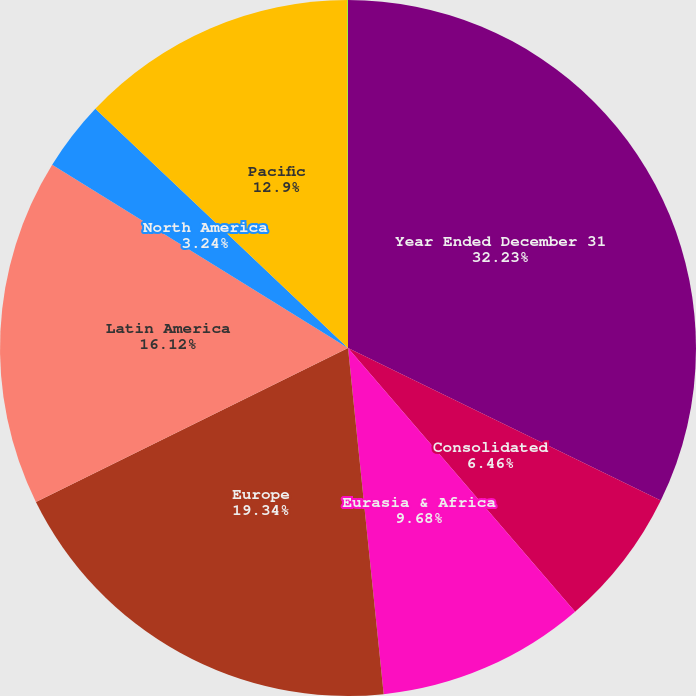Convert chart. <chart><loc_0><loc_0><loc_500><loc_500><pie_chart><fcel>Year Ended December 31<fcel>Consolidated<fcel>Eurasia & Africa<fcel>Europe<fcel>Latin America<fcel>North America<fcel>Pacific<fcel>Bottling Investments<nl><fcel>32.22%<fcel>6.46%<fcel>9.68%<fcel>19.34%<fcel>16.12%<fcel>3.24%<fcel>12.9%<fcel>0.03%<nl></chart> 